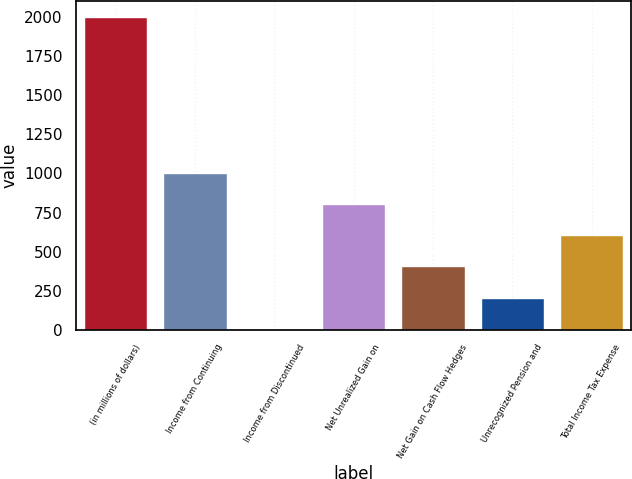Convert chart to OTSL. <chart><loc_0><loc_0><loc_500><loc_500><bar_chart><fcel>(in millions of dollars)<fcel>Income from Continuing<fcel>Income from Discontinued<fcel>Net Unrealized Gain on<fcel>Net Gain on Cash Flow Hedges<fcel>Unrecognized Pension and<fcel>Total Income Tax Expense<nl><fcel>2005<fcel>1005.55<fcel>6.1<fcel>805.66<fcel>405.88<fcel>205.99<fcel>605.77<nl></chart> 